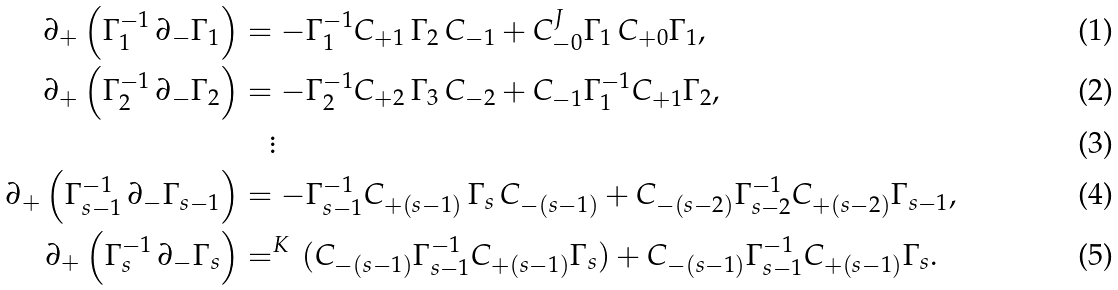Convert formula to latex. <formula><loc_0><loc_0><loc_500><loc_500>\partial _ { + } \left ( \Gamma _ { 1 } ^ { - 1 } \, \partial _ { - } \Gamma _ { 1 } \right ) & = - \Gamma _ { 1 } ^ { - 1 } C _ { + 1 } \, \Gamma _ { 2 } \, C _ { - 1 } + C _ { - 0 } ^ { J \, } \Gamma _ { 1 } \, C _ { + 0 } \Gamma _ { 1 } , \\ \partial _ { + } \left ( \Gamma _ { 2 } ^ { - 1 } \, \partial _ { - } \Gamma _ { 2 } \right ) & = - \Gamma _ { 2 } ^ { - 1 } C _ { + 2 } \, \Gamma _ { 3 } \, C _ { - 2 } + C _ { - 1 } \Gamma _ { 1 } ^ { - 1 } C _ { + 1 } \Gamma _ { 2 } , \\ & \quad \vdots \\ \partial _ { + } \left ( \Gamma _ { s - 1 } ^ { - 1 } \, \partial _ { - } \Gamma _ { s - 1 } \right ) & = - \Gamma _ { s - 1 } ^ { - 1 } C _ { + ( s - 1 ) } \, \Gamma _ { s } \, C _ { - ( s - 1 ) } + C _ { - ( s - 2 ) } \Gamma _ { s - 2 } ^ { - 1 } C _ { + ( s - 2 ) } \Gamma _ { s - 1 } , \\ \partial _ { + } \left ( \Gamma _ { s } ^ { - 1 } \, \partial _ { - } \Gamma _ { s } \right ) & = ^ { K \, } ( C _ { - ( s - 1 ) } \Gamma _ { s - 1 } ^ { - 1 } C _ { + ( s - 1 ) } \Gamma _ { s } ) + C _ { - ( s - 1 ) } \Gamma _ { s - 1 } ^ { - 1 } C _ { + ( s - 1 ) } \Gamma _ { s } .</formula> 